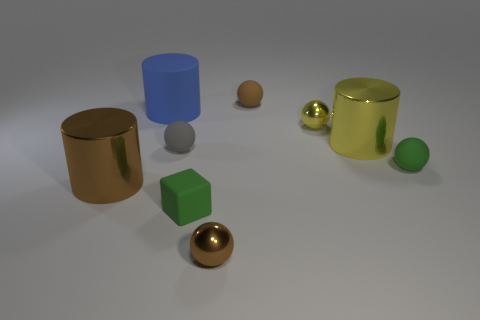Can you tell me which objects in the image are translucent? In the image, the blue object appears to have a translucent quality. Its material allows light to pass through, but not detailed shapes, which indicates its translucency. 